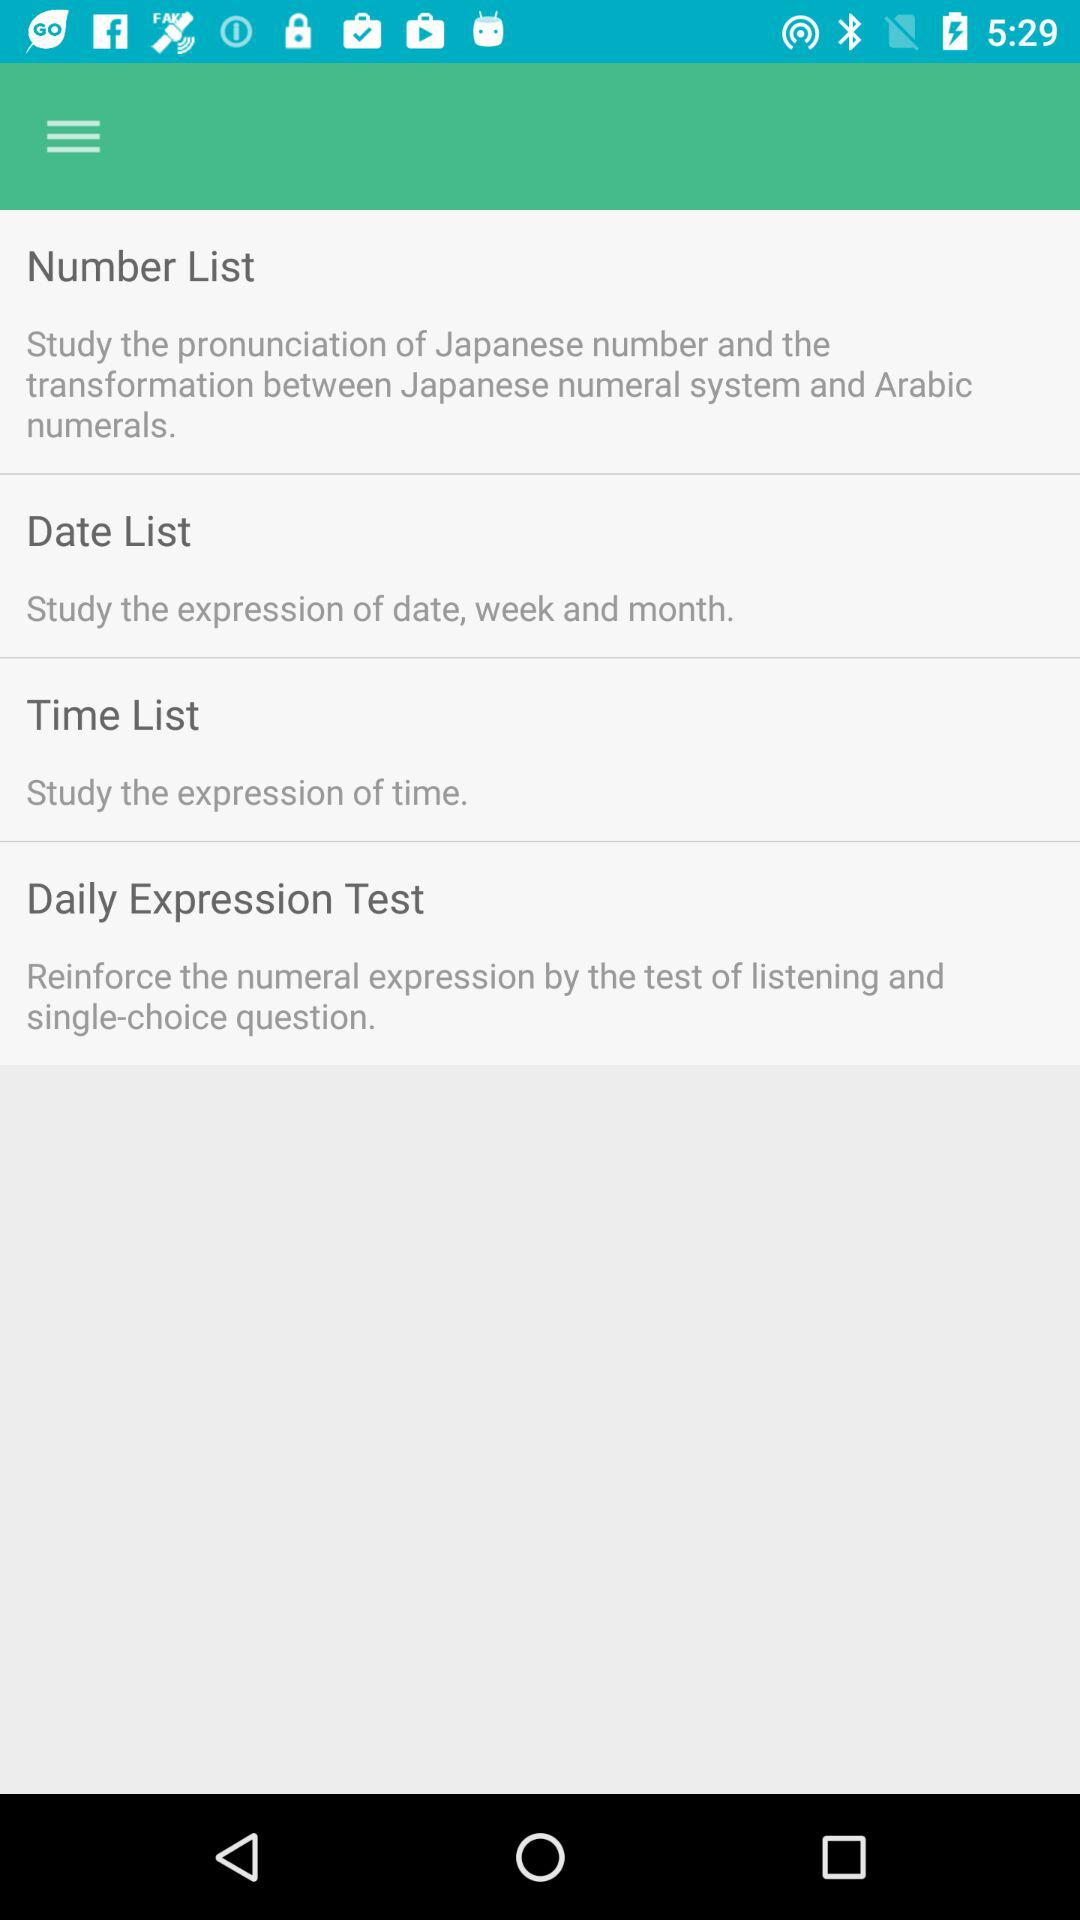What is the date list? The date list is a study of the expressions of date, week, and month. 